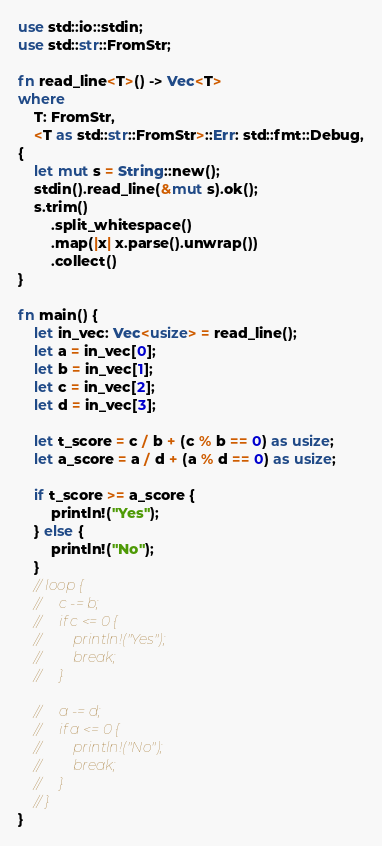<code> <loc_0><loc_0><loc_500><loc_500><_Rust_>use std::io::stdin;
use std::str::FromStr;

fn read_line<T>() -> Vec<T>
where
    T: FromStr,
    <T as std::str::FromStr>::Err: std::fmt::Debug,
{
    let mut s = String::new();
    stdin().read_line(&mut s).ok();
    s.trim()
        .split_whitespace()
        .map(|x| x.parse().unwrap())
        .collect()
}

fn main() {
    let in_vec: Vec<usize> = read_line();
    let a = in_vec[0];
    let b = in_vec[1];
    let c = in_vec[2];
    let d = in_vec[3];

    let t_score = c / b + (c % b == 0) as usize;
    let a_score = a / d + (a % d == 0) as usize;

    if t_score >= a_score {
        println!("Yes");
    } else {
        println!("No");
    }
    // loop {
    //     c -= b;
    //     if c <= 0 {
    //         println!("Yes");
    //         break;
    //     }

    //     a -= d;
    //     if a <= 0 {
    //         println!("No");
    //         break;
    //     }
    // }
}
</code> 